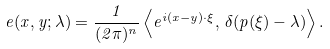Convert formula to latex. <formula><loc_0><loc_0><loc_500><loc_500>e ( x , y ; \lambda ) = \frac { 1 } { ( 2 \pi ) ^ { n } } \left \langle e ^ { i ( x - y ) \cdot \xi } , \, \delta ( p ( \xi ) - \lambda ) \right \rangle .</formula> 